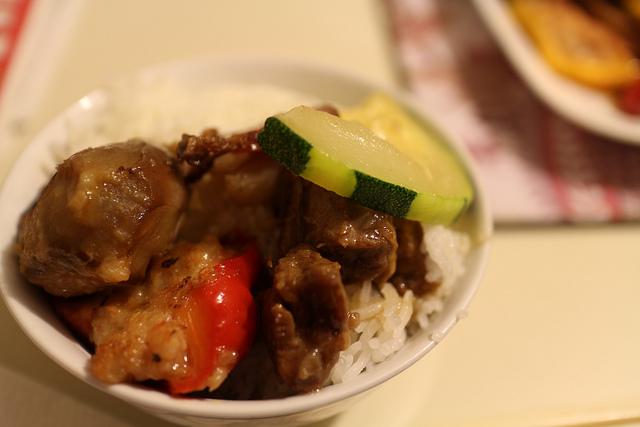Is the bowl filled with meat and rice?
Be succinct. Yes. Is this a main dish or a side dish?
Answer briefly. Side. Has the cucumber had some of the skin shaved from it before being sliced?
Keep it brief. Yes. 